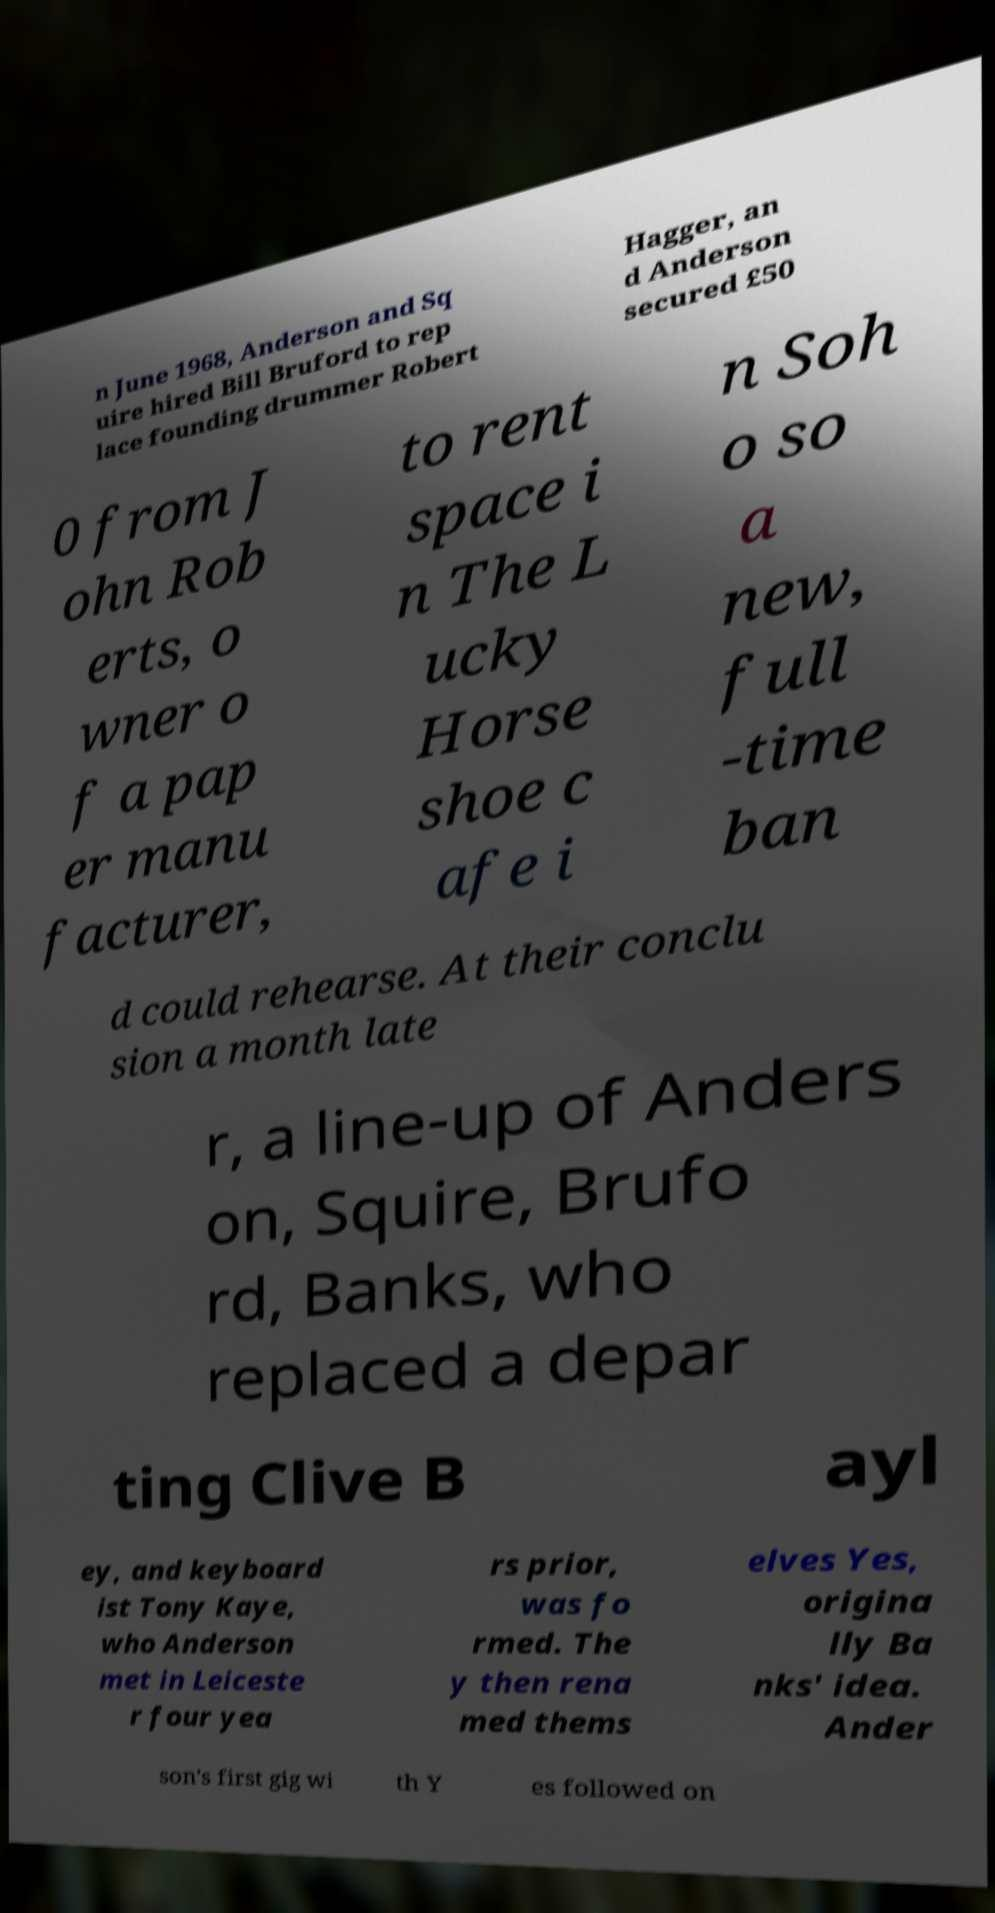Can you read and provide the text displayed in the image?This photo seems to have some interesting text. Can you extract and type it out for me? n June 1968, Anderson and Sq uire hired Bill Bruford to rep lace founding drummer Robert Hagger, an d Anderson secured £50 0 from J ohn Rob erts, o wner o f a pap er manu facturer, to rent space i n The L ucky Horse shoe c afe i n Soh o so a new, full -time ban d could rehearse. At their conclu sion a month late r, a line-up of Anders on, Squire, Brufo rd, Banks, who replaced a depar ting Clive B ayl ey, and keyboard ist Tony Kaye, who Anderson met in Leiceste r four yea rs prior, was fo rmed. The y then rena med thems elves Yes, origina lly Ba nks' idea. Ander son's first gig wi th Y es followed on 